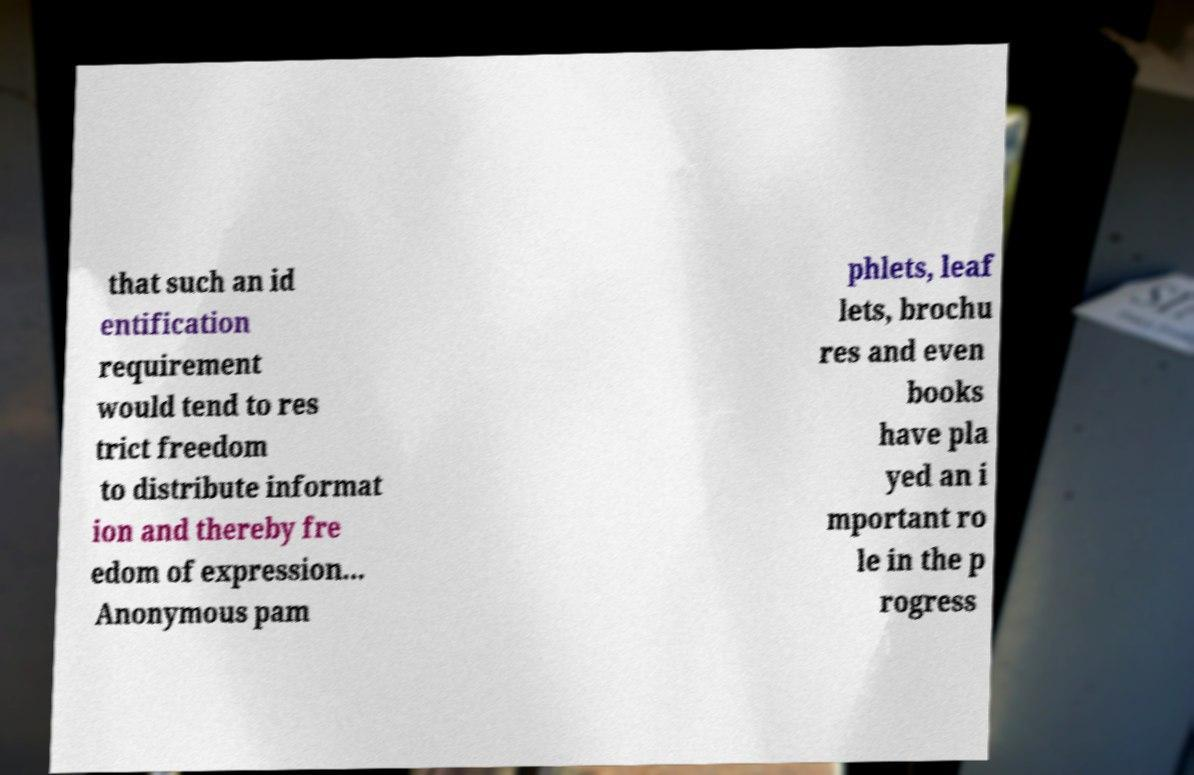There's text embedded in this image that I need extracted. Can you transcribe it verbatim? that such an id entification requirement would tend to res trict freedom to distribute informat ion and thereby fre edom of expression... Anonymous pam phlets, leaf lets, brochu res and even books have pla yed an i mportant ro le in the p rogress 